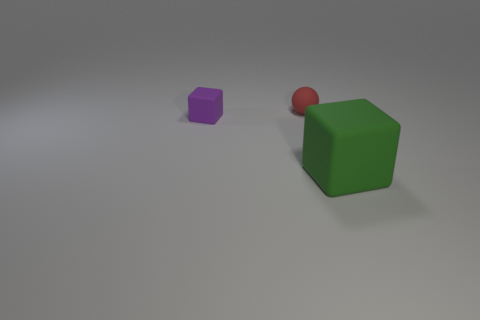How many matte things are big things or small blue cylinders?
Keep it short and to the point. 1. What number of small purple blocks are on the left side of the small purple rubber cube?
Provide a short and direct response. 0. Are there any other matte things of the same size as the red object?
Give a very brief answer. Yes. Is there another sphere of the same color as the rubber ball?
Provide a succinct answer. No. Is there anything else that has the same size as the red sphere?
Your response must be concise. Yes. What number of large cubes are the same color as the small rubber block?
Your answer should be very brief. 0. Do the big object and the tiny object behind the small rubber cube have the same color?
Your response must be concise. No. What number of things are either tiny red metal cylinders or rubber blocks that are to the left of the big block?
Keep it short and to the point. 1. There is a cube on the right side of the rubber block that is behind the large green thing; how big is it?
Your answer should be compact. Large. Are there an equal number of small matte things to the right of the green rubber object and large green blocks to the left of the purple matte block?
Ensure brevity in your answer.  Yes. 